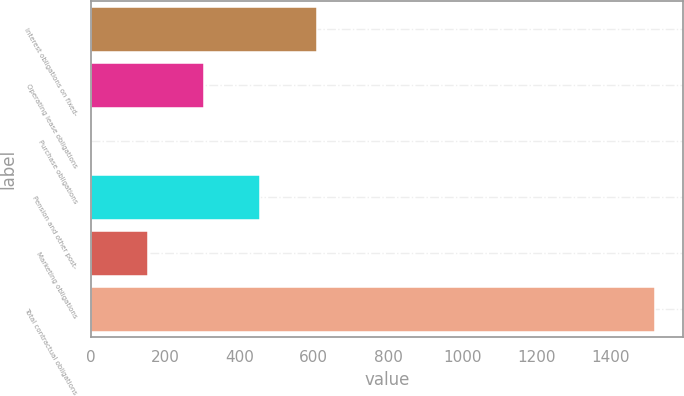Convert chart to OTSL. <chart><loc_0><loc_0><loc_500><loc_500><bar_chart><fcel>Interest obligations on fixed-<fcel>Operating lease obligations<fcel>Purchase obligations<fcel>Pension and other post-<fcel>Marketing obligations<fcel>Total contractual obligations<nl><fcel>608.22<fcel>304.16<fcel>0.1<fcel>456.19<fcel>152.13<fcel>1520.4<nl></chart> 